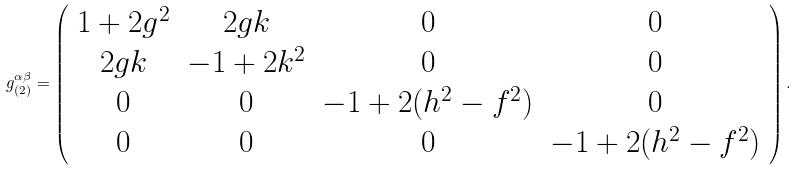<formula> <loc_0><loc_0><loc_500><loc_500>g _ { ( 2 ) } ^ { \alpha \beta } = \left ( \begin{array} { c c c c } 1 + 2 g ^ { 2 } & 2 g k & 0 & 0 \\ 2 g k & - 1 + 2 k ^ { 2 } & 0 & 0 \\ 0 & 0 & - 1 + 2 ( h ^ { 2 } - f ^ { 2 } ) & 0 \\ 0 & 0 & 0 & - 1 + 2 ( h ^ { 2 } - f ^ { 2 } ) \end{array} \right ) .</formula> 